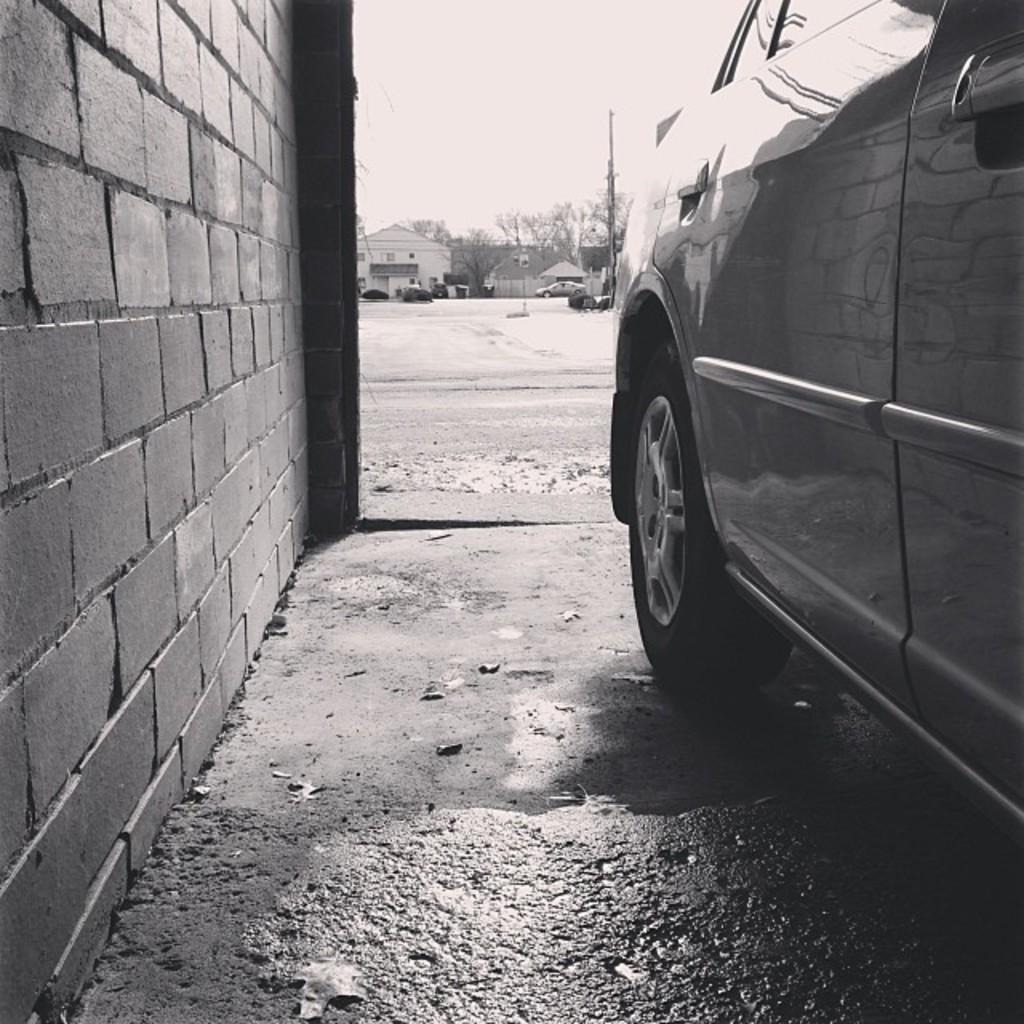What is the color scheme of the image? The image is black and white. What types of structures can be seen in the image? There are houses and walls visible in the image. What other objects are present in the image? There are vehicles, trees, and poles in the image. What can be seen in the background of the image? The sky is visible in the background of the image. Can you see any feathers floating in the sky in the image? There are no feathers visible in the image; it is a black and white image featuring houses, walls, vehicles, trees, and poles. What fact can be learned about the image from the given information? The fact that can be learned from the given information is that the image is black and white and contains various structures and objects, including houses, walls, vehicles, trees, and poles. 